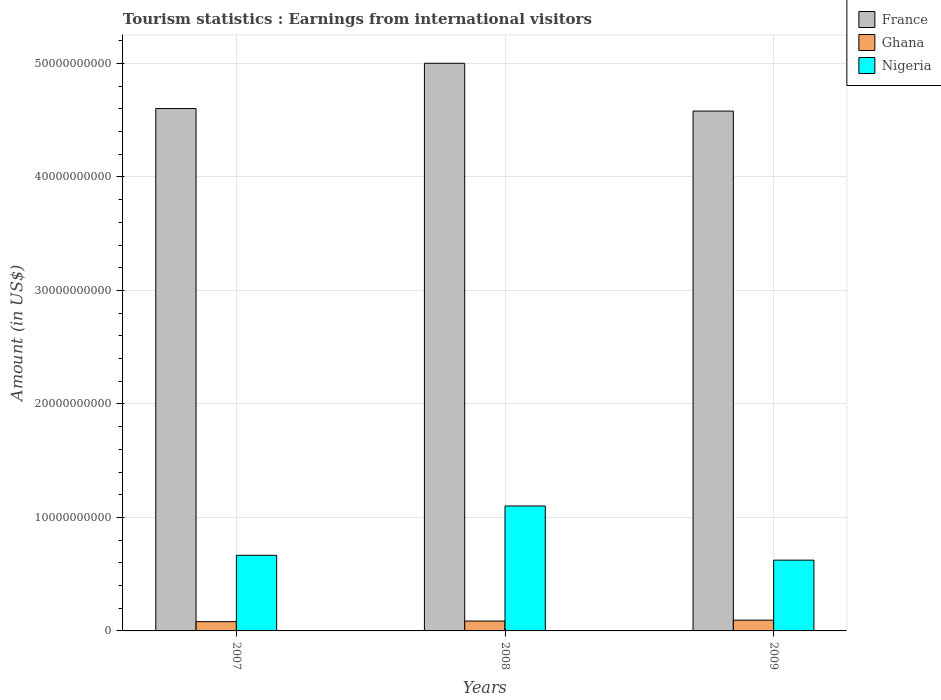How many different coloured bars are there?
Make the answer very short. 3. Are the number of bars per tick equal to the number of legend labels?
Your response must be concise. Yes. How many bars are there on the 3rd tick from the right?
Your response must be concise. 3. What is the label of the 2nd group of bars from the left?
Your response must be concise. 2008. In how many cases, is the number of bars for a given year not equal to the number of legend labels?
Offer a terse response. 0. What is the earnings from international visitors in France in 2009?
Your answer should be very brief. 4.58e+1. Across all years, what is the maximum earnings from international visitors in Nigeria?
Offer a very short reply. 1.10e+1. Across all years, what is the minimum earnings from international visitors in France?
Provide a succinct answer. 4.58e+1. What is the total earnings from international visitors in France in the graph?
Your answer should be compact. 1.42e+11. What is the difference between the earnings from international visitors in Ghana in 2007 and that in 2008?
Your answer should be compact. -5.40e+07. What is the difference between the earnings from international visitors in Nigeria in 2007 and the earnings from international visitors in Ghana in 2009?
Your answer should be compact. 5.72e+09. What is the average earnings from international visitors in France per year?
Provide a short and direct response. 4.73e+1. In the year 2009, what is the difference between the earnings from international visitors in Ghana and earnings from international visitors in Nigeria?
Make the answer very short. -5.29e+09. What is the ratio of the earnings from international visitors in Ghana in 2007 to that in 2009?
Offer a very short reply. 0.86. Is the earnings from international visitors in Nigeria in 2007 less than that in 2009?
Offer a terse response. No. Is the difference between the earnings from international visitors in Ghana in 2008 and 2009 greater than the difference between the earnings from international visitors in Nigeria in 2008 and 2009?
Offer a terse response. No. What is the difference between the highest and the second highest earnings from international visitors in Ghana?
Offer a very short reply. 7.80e+07. What is the difference between the highest and the lowest earnings from international visitors in France?
Offer a terse response. 4.22e+09. What does the 3rd bar from the left in 2007 represents?
Your answer should be very brief. Nigeria. What does the 3rd bar from the right in 2009 represents?
Keep it short and to the point. France. How many bars are there?
Your answer should be very brief. 9. How many years are there in the graph?
Your answer should be compact. 3. What is the difference between two consecutive major ticks on the Y-axis?
Provide a succinct answer. 1.00e+1. Where does the legend appear in the graph?
Keep it short and to the point. Top right. How many legend labels are there?
Ensure brevity in your answer.  3. How are the legend labels stacked?
Make the answer very short. Vertical. What is the title of the graph?
Your response must be concise. Tourism statistics : Earnings from international visitors. What is the label or title of the Y-axis?
Your answer should be compact. Amount (in US$). What is the Amount (in US$) of France in 2007?
Your response must be concise. 4.60e+1. What is the Amount (in US$) in Ghana in 2007?
Provide a short and direct response. 8.16e+08. What is the Amount (in US$) of Nigeria in 2007?
Provide a short and direct response. 6.66e+09. What is the Amount (in US$) in France in 2008?
Offer a terse response. 5.00e+1. What is the Amount (in US$) of Ghana in 2008?
Offer a very short reply. 8.70e+08. What is the Amount (in US$) in Nigeria in 2008?
Your answer should be compact. 1.10e+1. What is the Amount (in US$) in France in 2009?
Give a very brief answer. 4.58e+1. What is the Amount (in US$) of Ghana in 2009?
Offer a very short reply. 9.48e+08. What is the Amount (in US$) in Nigeria in 2009?
Offer a terse response. 6.24e+09. Across all years, what is the maximum Amount (in US$) of France?
Ensure brevity in your answer.  5.00e+1. Across all years, what is the maximum Amount (in US$) of Ghana?
Your response must be concise. 9.48e+08. Across all years, what is the maximum Amount (in US$) in Nigeria?
Provide a succinct answer. 1.10e+1. Across all years, what is the minimum Amount (in US$) of France?
Offer a terse response. 4.58e+1. Across all years, what is the minimum Amount (in US$) in Ghana?
Provide a succinct answer. 8.16e+08. Across all years, what is the minimum Amount (in US$) of Nigeria?
Keep it short and to the point. 6.24e+09. What is the total Amount (in US$) of France in the graph?
Ensure brevity in your answer.  1.42e+11. What is the total Amount (in US$) of Ghana in the graph?
Your answer should be very brief. 2.63e+09. What is the total Amount (in US$) in Nigeria in the graph?
Your answer should be very brief. 2.39e+1. What is the difference between the Amount (in US$) in France in 2007 and that in 2008?
Your answer should be compact. -3.99e+09. What is the difference between the Amount (in US$) in Ghana in 2007 and that in 2008?
Provide a short and direct response. -5.40e+07. What is the difference between the Amount (in US$) of Nigeria in 2007 and that in 2008?
Provide a short and direct response. -4.34e+09. What is the difference between the Amount (in US$) in France in 2007 and that in 2009?
Your response must be concise. 2.23e+08. What is the difference between the Amount (in US$) in Ghana in 2007 and that in 2009?
Give a very brief answer. -1.32e+08. What is the difference between the Amount (in US$) in Nigeria in 2007 and that in 2009?
Offer a very short reply. 4.28e+08. What is the difference between the Amount (in US$) of France in 2008 and that in 2009?
Your answer should be compact. 4.22e+09. What is the difference between the Amount (in US$) of Ghana in 2008 and that in 2009?
Provide a succinct answer. -7.80e+07. What is the difference between the Amount (in US$) in Nigeria in 2008 and that in 2009?
Provide a short and direct response. 4.77e+09. What is the difference between the Amount (in US$) of France in 2007 and the Amount (in US$) of Ghana in 2008?
Keep it short and to the point. 4.52e+1. What is the difference between the Amount (in US$) in France in 2007 and the Amount (in US$) in Nigeria in 2008?
Provide a short and direct response. 3.50e+1. What is the difference between the Amount (in US$) in Ghana in 2007 and the Amount (in US$) in Nigeria in 2008?
Offer a very short reply. -1.02e+1. What is the difference between the Amount (in US$) in France in 2007 and the Amount (in US$) in Ghana in 2009?
Provide a short and direct response. 4.51e+1. What is the difference between the Amount (in US$) of France in 2007 and the Amount (in US$) of Nigeria in 2009?
Offer a terse response. 3.98e+1. What is the difference between the Amount (in US$) of Ghana in 2007 and the Amount (in US$) of Nigeria in 2009?
Keep it short and to the point. -5.42e+09. What is the difference between the Amount (in US$) of France in 2008 and the Amount (in US$) of Ghana in 2009?
Your answer should be very brief. 4.91e+1. What is the difference between the Amount (in US$) of France in 2008 and the Amount (in US$) of Nigeria in 2009?
Keep it short and to the point. 4.38e+1. What is the difference between the Amount (in US$) in Ghana in 2008 and the Amount (in US$) in Nigeria in 2009?
Your answer should be compact. -5.37e+09. What is the average Amount (in US$) in France per year?
Provide a short and direct response. 4.73e+1. What is the average Amount (in US$) of Ghana per year?
Offer a terse response. 8.78e+08. What is the average Amount (in US$) in Nigeria per year?
Provide a short and direct response. 7.97e+09. In the year 2007, what is the difference between the Amount (in US$) in France and Amount (in US$) in Ghana?
Offer a terse response. 4.52e+1. In the year 2007, what is the difference between the Amount (in US$) in France and Amount (in US$) in Nigeria?
Your response must be concise. 3.94e+1. In the year 2007, what is the difference between the Amount (in US$) in Ghana and Amount (in US$) in Nigeria?
Your answer should be very brief. -5.85e+09. In the year 2008, what is the difference between the Amount (in US$) of France and Amount (in US$) of Ghana?
Make the answer very short. 4.92e+1. In the year 2008, what is the difference between the Amount (in US$) in France and Amount (in US$) in Nigeria?
Ensure brevity in your answer.  3.90e+1. In the year 2008, what is the difference between the Amount (in US$) of Ghana and Amount (in US$) of Nigeria?
Make the answer very short. -1.01e+1. In the year 2009, what is the difference between the Amount (in US$) in France and Amount (in US$) in Ghana?
Offer a terse response. 4.49e+1. In the year 2009, what is the difference between the Amount (in US$) of France and Amount (in US$) of Nigeria?
Your response must be concise. 3.96e+1. In the year 2009, what is the difference between the Amount (in US$) of Ghana and Amount (in US$) of Nigeria?
Provide a short and direct response. -5.29e+09. What is the ratio of the Amount (in US$) in France in 2007 to that in 2008?
Offer a terse response. 0.92. What is the ratio of the Amount (in US$) of Ghana in 2007 to that in 2008?
Give a very brief answer. 0.94. What is the ratio of the Amount (in US$) of Nigeria in 2007 to that in 2008?
Your response must be concise. 0.61. What is the ratio of the Amount (in US$) of France in 2007 to that in 2009?
Keep it short and to the point. 1. What is the ratio of the Amount (in US$) in Ghana in 2007 to that in 2009?
Your answer should be compact. 0.86. What is the ratio of the Amount (in US$) in Nigeria in 2007 to that in 2009?
Offer a very short reply. 1.07. What is the ratio of the Amount (in US$) in France in 2008 to that in 2009?
Offer a very short reply. 1.09. What is the ratio of the Amount (in US$) of Ghana in 2008 to that in 2009?
Offer a very short reply. 0.92. What is the ratio of the Amount (in US$) of Nigeria in 2008 to that in 2009?
Offer a very short reply. 1.77. What is the difference between the highest and the second highest Amount (in US$) of France?
Offer a very short reply. 3.99e+09. What is the difference between the highest and the second highest Amount (in US$) of Ghana?
Your answer should be very brief. 7.80e+07. What is the difference between the highest and the second highest Amount (in US$) of Nigeria?
Your response must be concise. 4.34e+09. What is the difference between the highest and the lowest Amount (in US$) in France?
Your response must be concise. 4.22e+09. What is the difference between the highest and the lowest Amount (in US$) of Ghana?
Ensure brevity in your answer.  1.32e+08. What is the difference between the highest and the lowest Amount (in US$) in Nigeria?
Your answer should be very brief. 4.77e+09. 